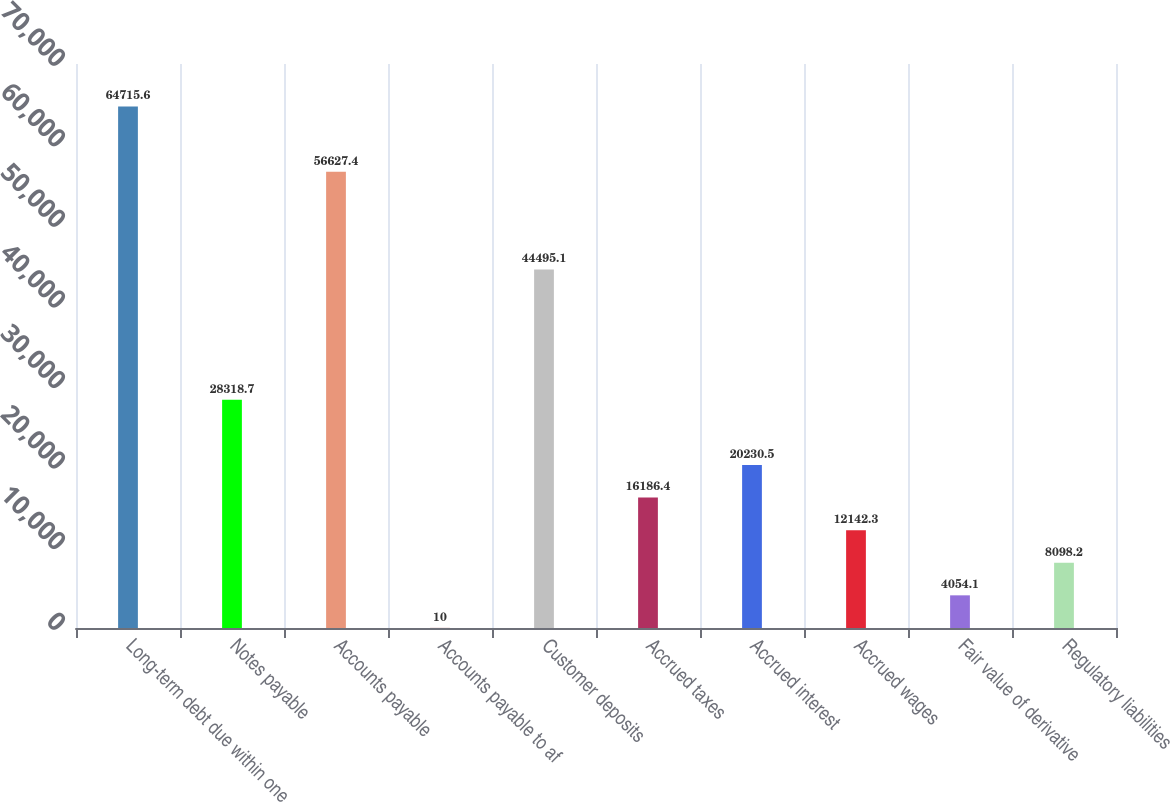<chart> <loc_0><loc_0><loc_500><loc_500><bar_chart><fcel>Long-term debt due within one<fcel>Notes payable<fcel>Accounts payable<fcel>Accounts payable to af<fcel>Customer deposits<fcel>Accrued taxes<fcel>Accrued interest<fcel>Accrued wages<fcel>Fair value of derivative<fcel>Regulatory liabilities<nl><fcel>64715.6<fcel>28318.7<fcel>56627.4<fcel>10<fcel>44495.1<fcel>16186.4<fcel>20230.5<fcel>12142.3<fcel>4054.1<fcel>8098.2<nl></chart> 